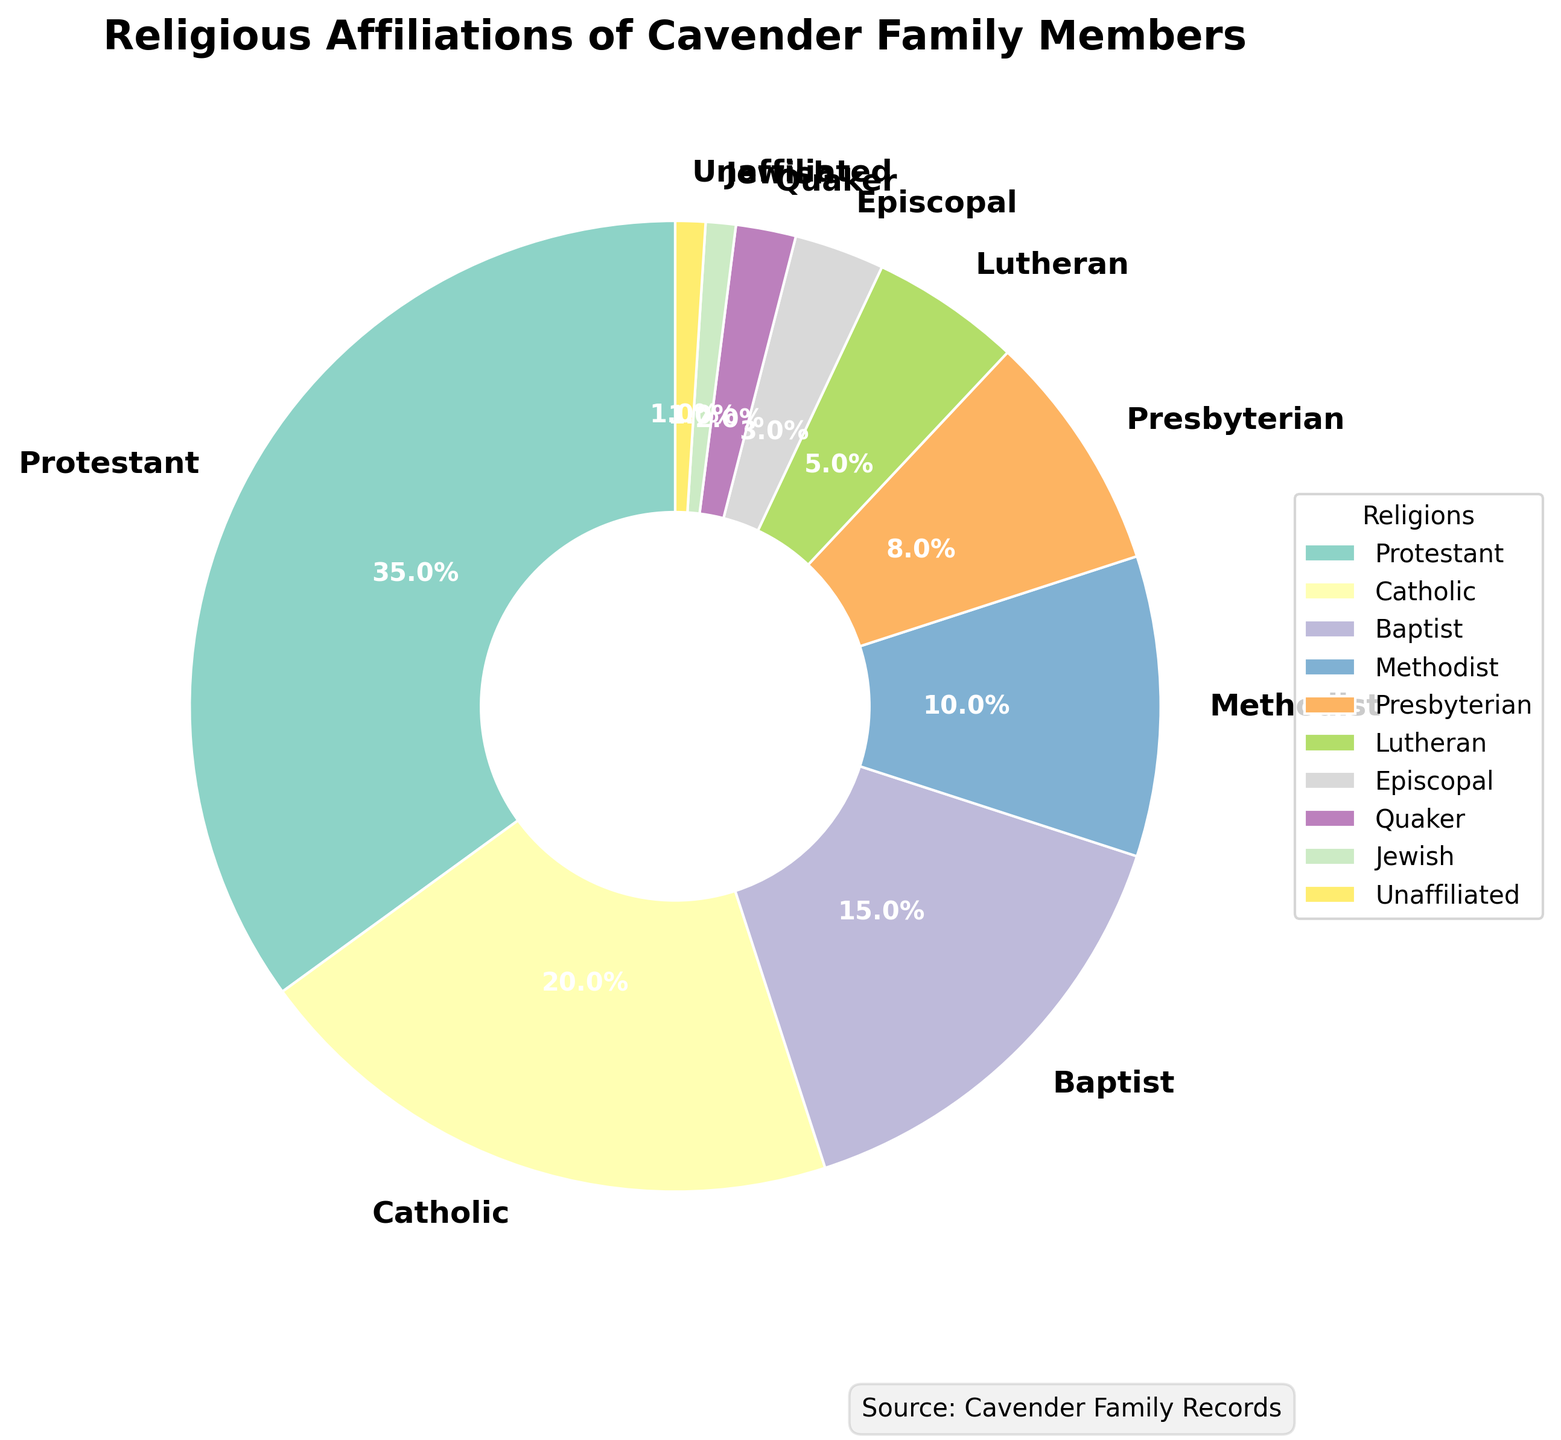Which religious affiliation has the highest percentage in the Cavender family? By observing the pie chart, the segment labeled "Protestant" occupies the largest portion.
Answer: Protestant How many religions are represented in the Cavender family? Counting the labels around the pie chart, there are 10 distinct religious affiliations.
Answer: 10 What's the combined percentage of Protestant and Catholic members in the Cavender family? The pie chart shows that Protestant is 35% and Catholic is 20%. Adding them together, we get 35% + 20% = 55%.
Answer: 55% Which religious affiliation has the smallest representation in the Cavender family? The pie chart indicates that both Jewish and Unaffiliated are represented by the smallest segments, each occupying 1%.
Answer: Jewish and Unaffiliated Which groups have a representation greater than 10%? By examining the pie chart, we see that the Protestant (35%), Catholic (20%), and Baptist (15%) segments are all greater than 10%.
Answer: Protestant, Catholic, and Baptist How does the percentage of Baptists compare to the percentage of Methodists within the Cavender family? On the pie chart, Baptists account for 15%, while Methodists account for 10%. Thus, Baptists have a 5% higher representation than Methodists.
Answer: Baptists have a higher representation What's the combined representation of Quaker, Jewish, and Unaffiliated members? Looking at the pie chart, Quaker is 2%, Jewish is 1%, and Unaffiliated is 1%. Adding them, we get 2% + 1% + 1% = 4%.
Answer: 4% How many religious affiliations have a representation below 5%? Observing the pie chart, Quaker (2%), Jewish (1%), and Unaffiliated (1%) are each below 5%, making a total of three.
Answer: Three What percentage of the family members belong to Christian denominations (sum of all Christian denominations)? Summing the percentages of Protestant (35%), Catholic (20%), Baptist (15%), Methodist (10%), Presbyterian (8%), Lutheran (5%), and Episcopal (3%), we get 35% + 20% + 15% + 10% + 8% + 5% + 3% = 96%.
Answer: 96% Which denominations have a smaller percentage than Lutheran members in the Cavender family? The pie chart shows Lutheran at 5%. The segments smaller than Lutheran are Episcopal (3%), Quaker (2%), Jewish (1%), and Unaffiliated (1%).
Answer: Episcopal, Quaker, Jewish, Unaffiliated 